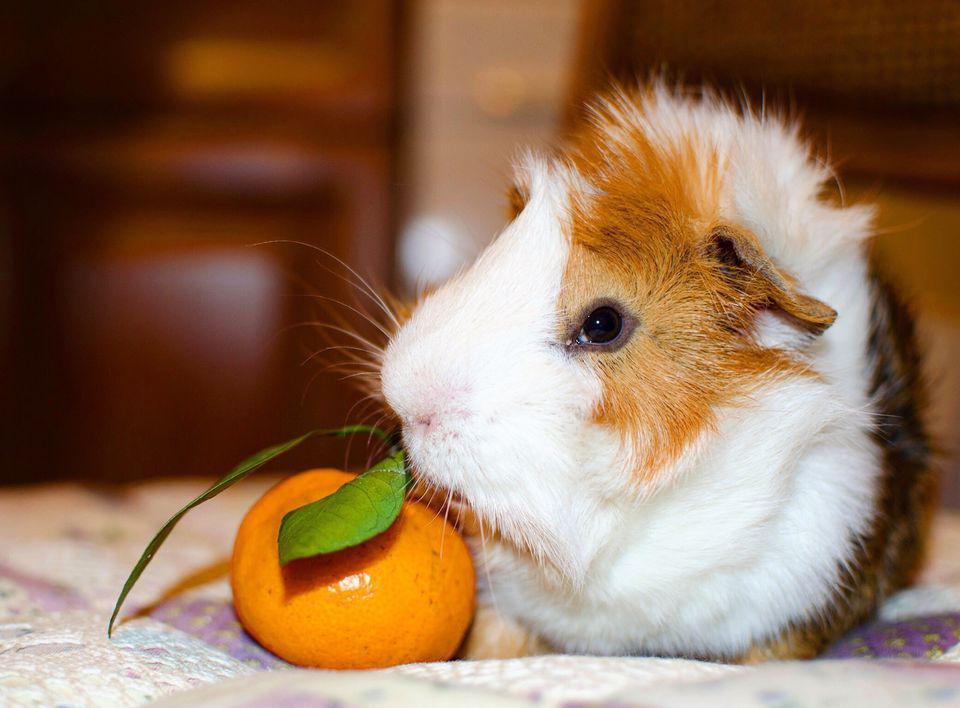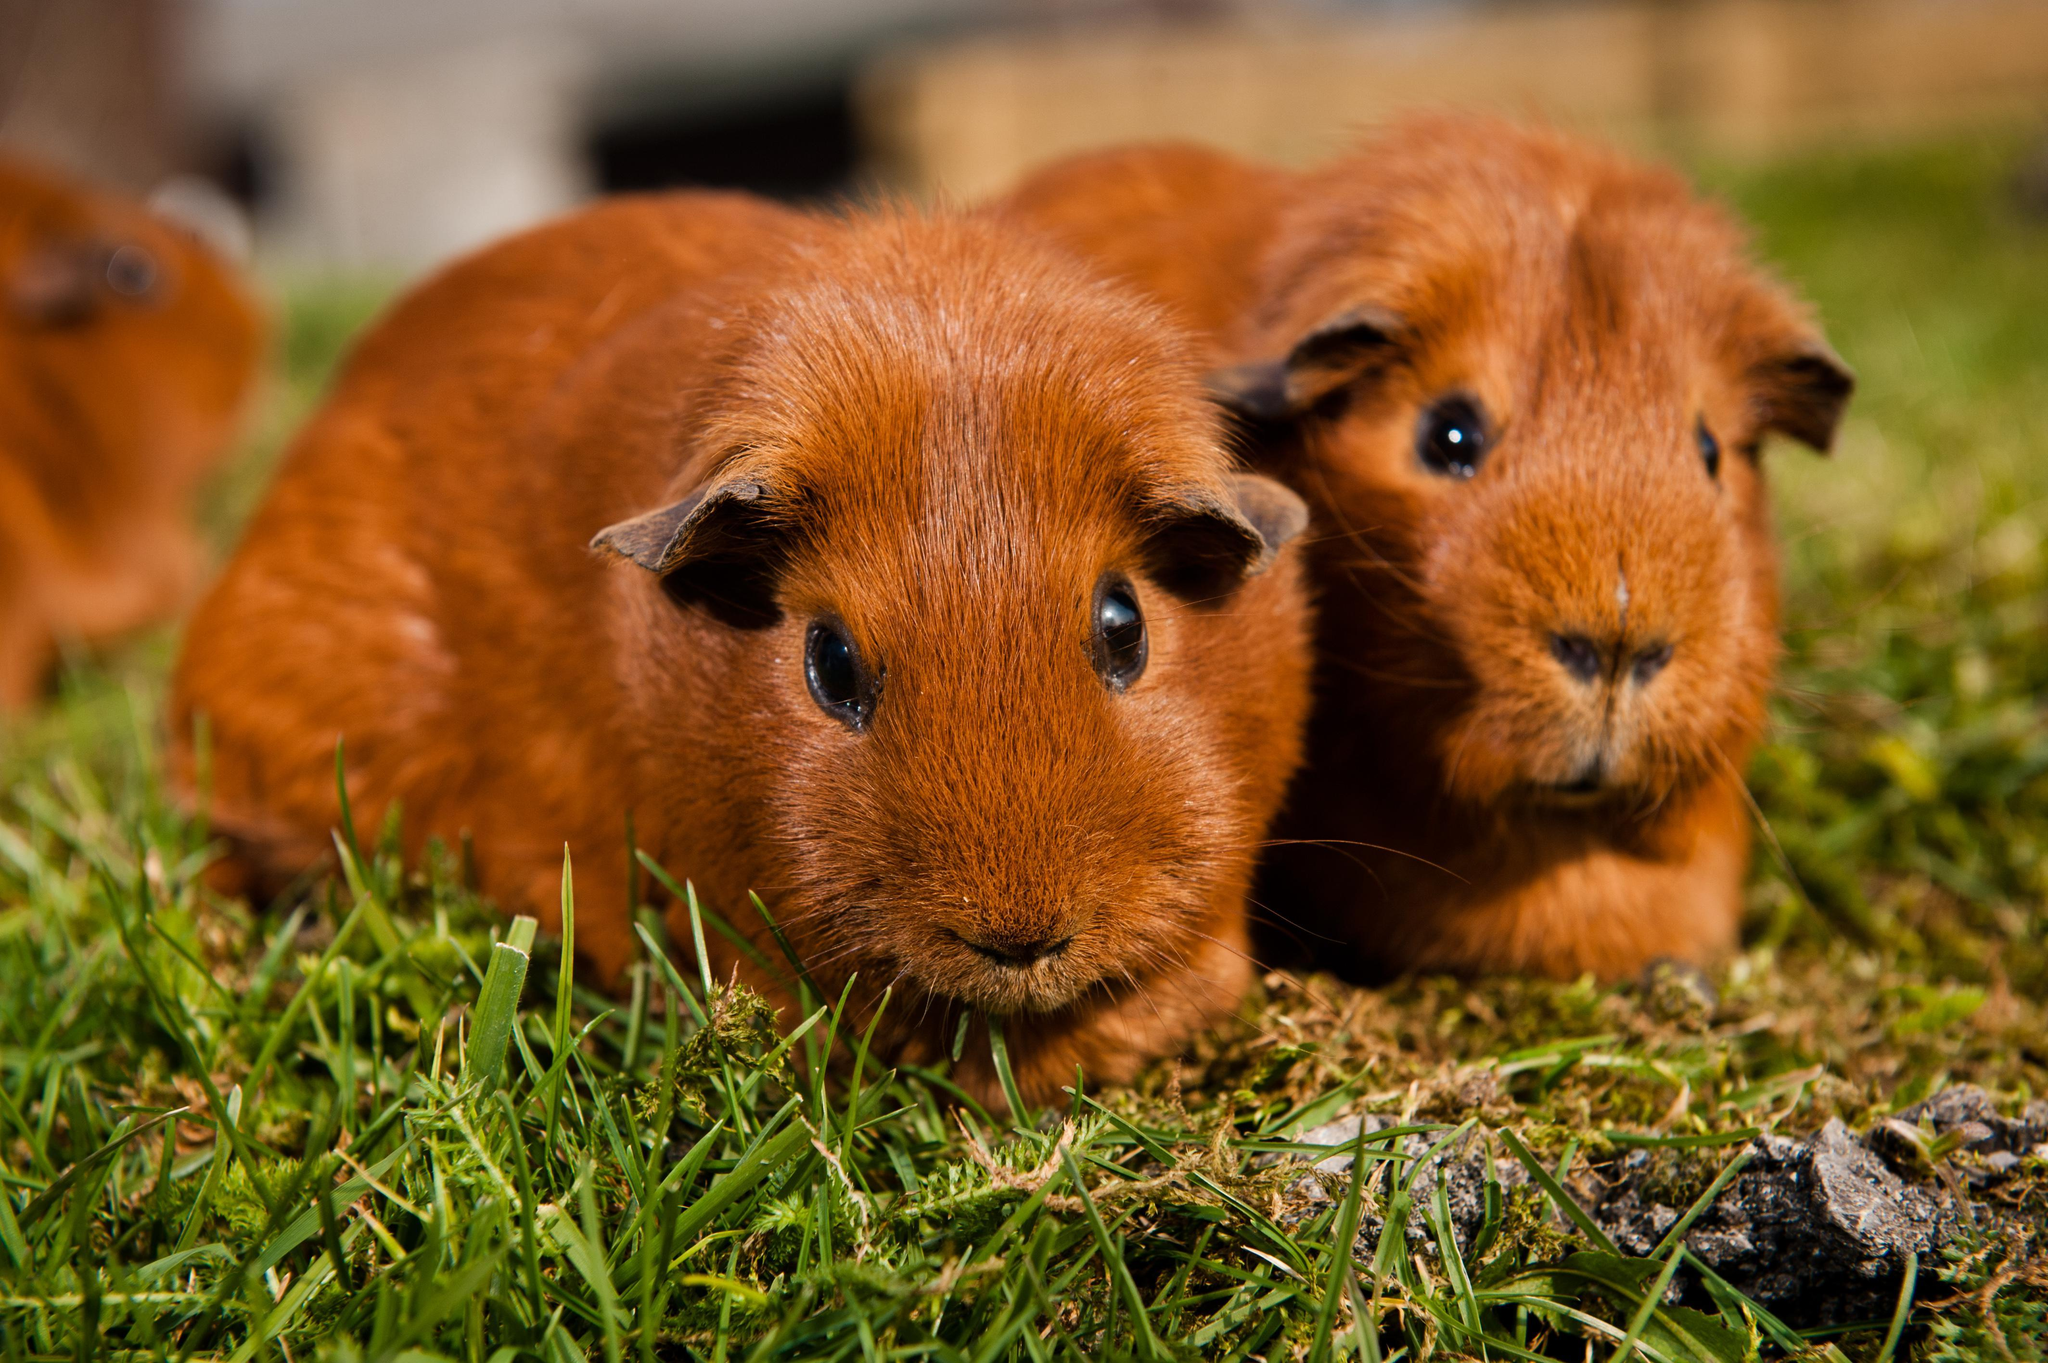The first image is the image on the left, the second image is the image on the right. Examine the images to the left and right. Is the description "The right image shows two guinea pigs and the left shows only one, and one of the images includes a bright orange object." accurate? Answer yes or no. Yes. The first image is the image on the left, the second image is the image on the right. Considering the images on both sides, is "There is at least one rodent sitting on the grass in the image on the right." valid? Answer yes or no. Yes. 